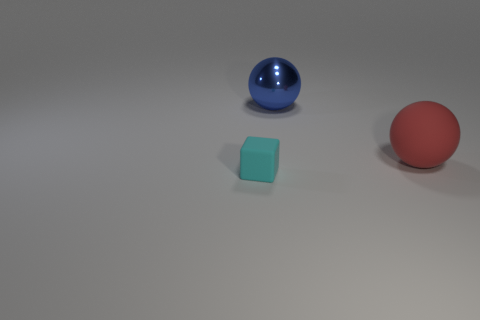Add 3 small yellow rubber blocks. How many objects exist? 6 Subtract all balls. How many objects are left? 1 Subtract 0 cyan cylinders. How many objects are left? 3 Subtract all brown cubes. Subtract all blue balls. How many cubes are left? 1 Subtract all red balls. Subtract all cyan objects. How many objects are left? 1 Add 3 metal objects. How many metal objects are left? 4 Add 1 small purple things. How many small purple things exist? 1 Subtract all blue balls. How many balls are left? 1 